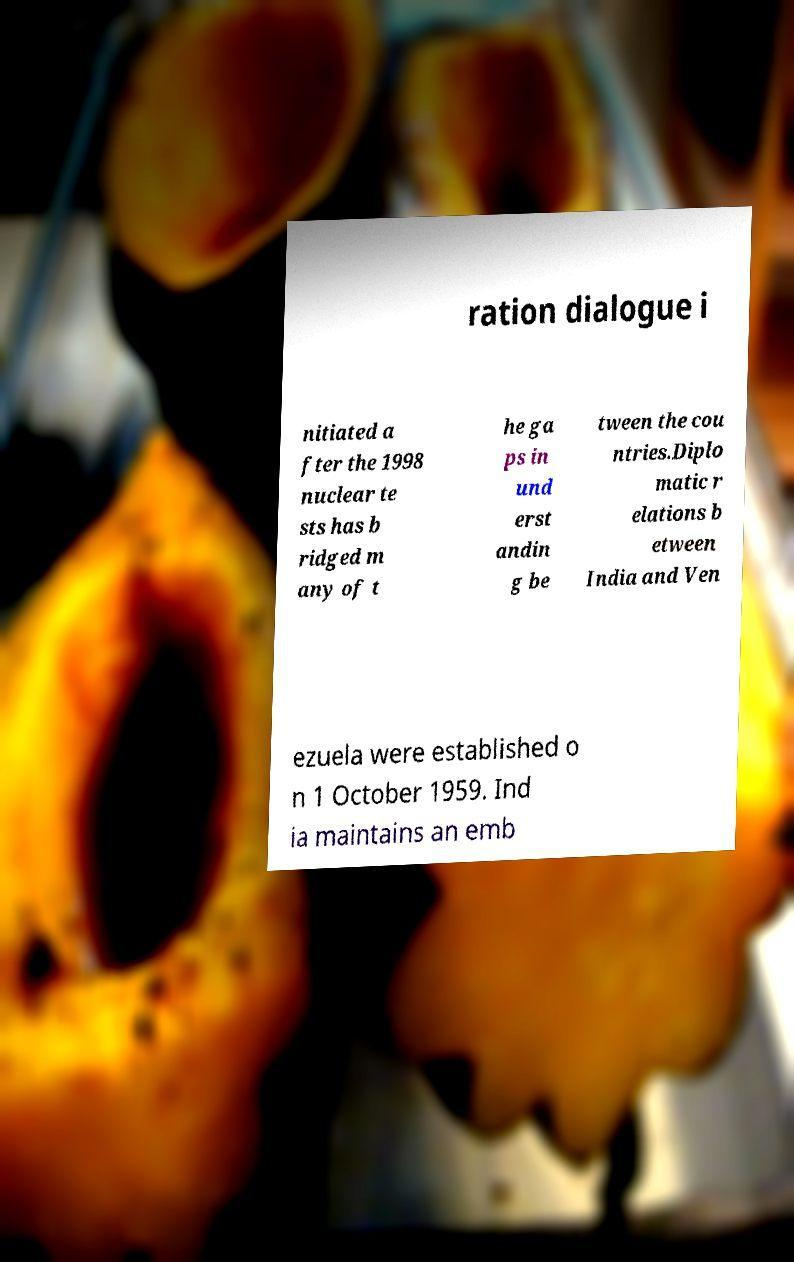For documentation purposes, I need the text within this image transcribed. Could you provide that? ration dialogue i nitiated a fter the 1998 nuclear te sts has b ridged m any of t he ga ps in und erst andin g be tween the cou ntries.Diplo matic r elations b etween India and Ven ezuela were established o n 1 October 1959. Ind ia maintains an emb 